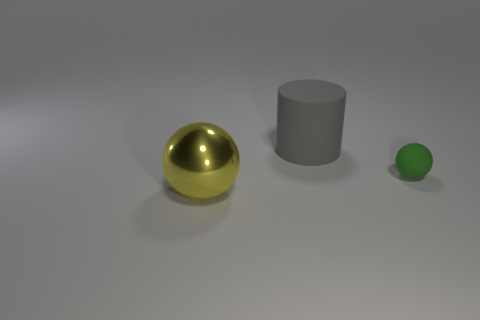Add 2 big rubber cylinders. How many objects exist? 5 Subtract all balls. How many objects are left? 1 Subtract 0 cyan cylinders. How many objects are left? 3 Subtract all brown matte objects. Subtract all matte objects. How many objects are left? 1 Add 1 large gray cylinders. How many large gray cylinders are left? 2 Add 1 small objects. How many small objects exist? 2 